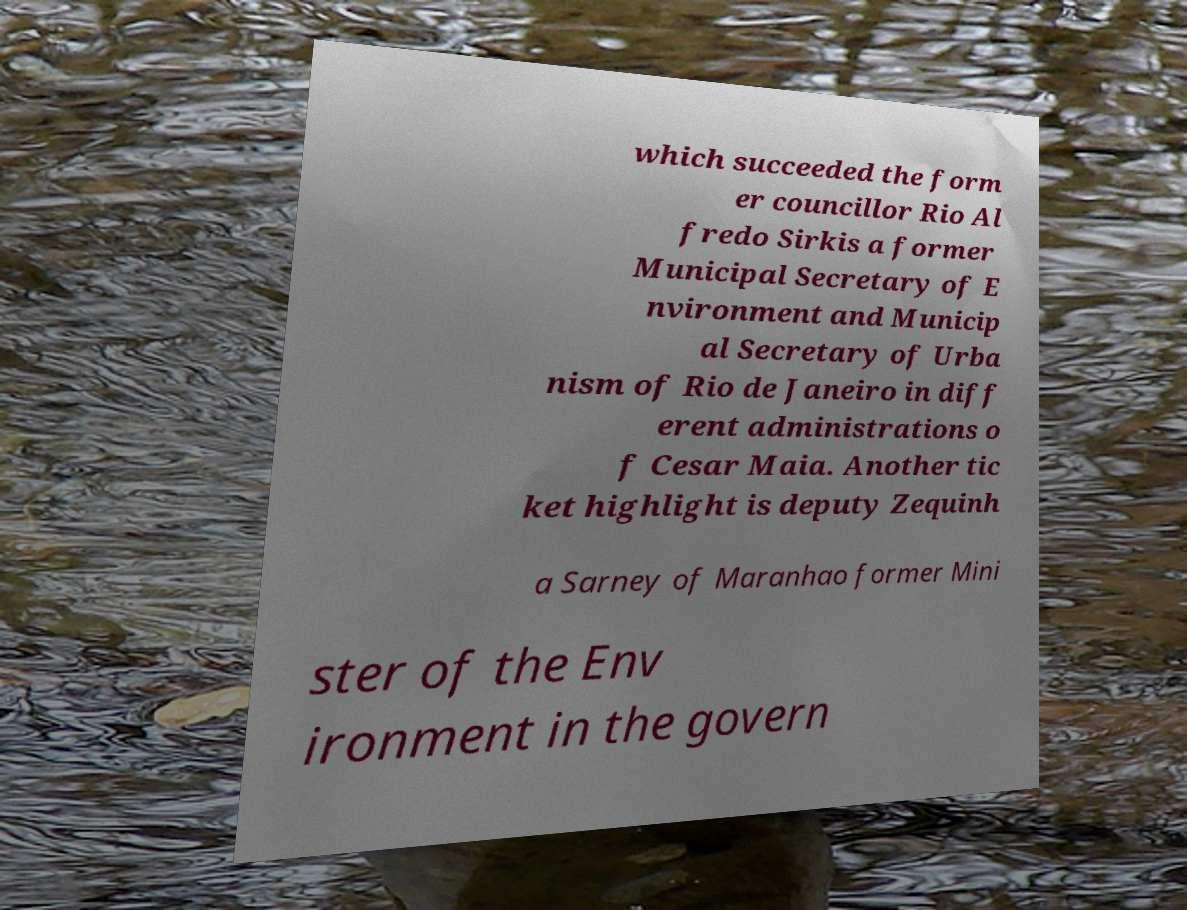What messages or text are displayed in this image? I need them in a readable, typed format. which succeeded the form er councillor Rio Al fredo Sirkis a former Municipal Secretary of E nvironment and Municip al Secretary of Urba nism of Rio de Janeiro in diff erent administrations o f Cesar Maia. Another tic ket highlight is deputy Zequinh a Sarney of Maranhao former Mini ster of the Env ironment in the govern 